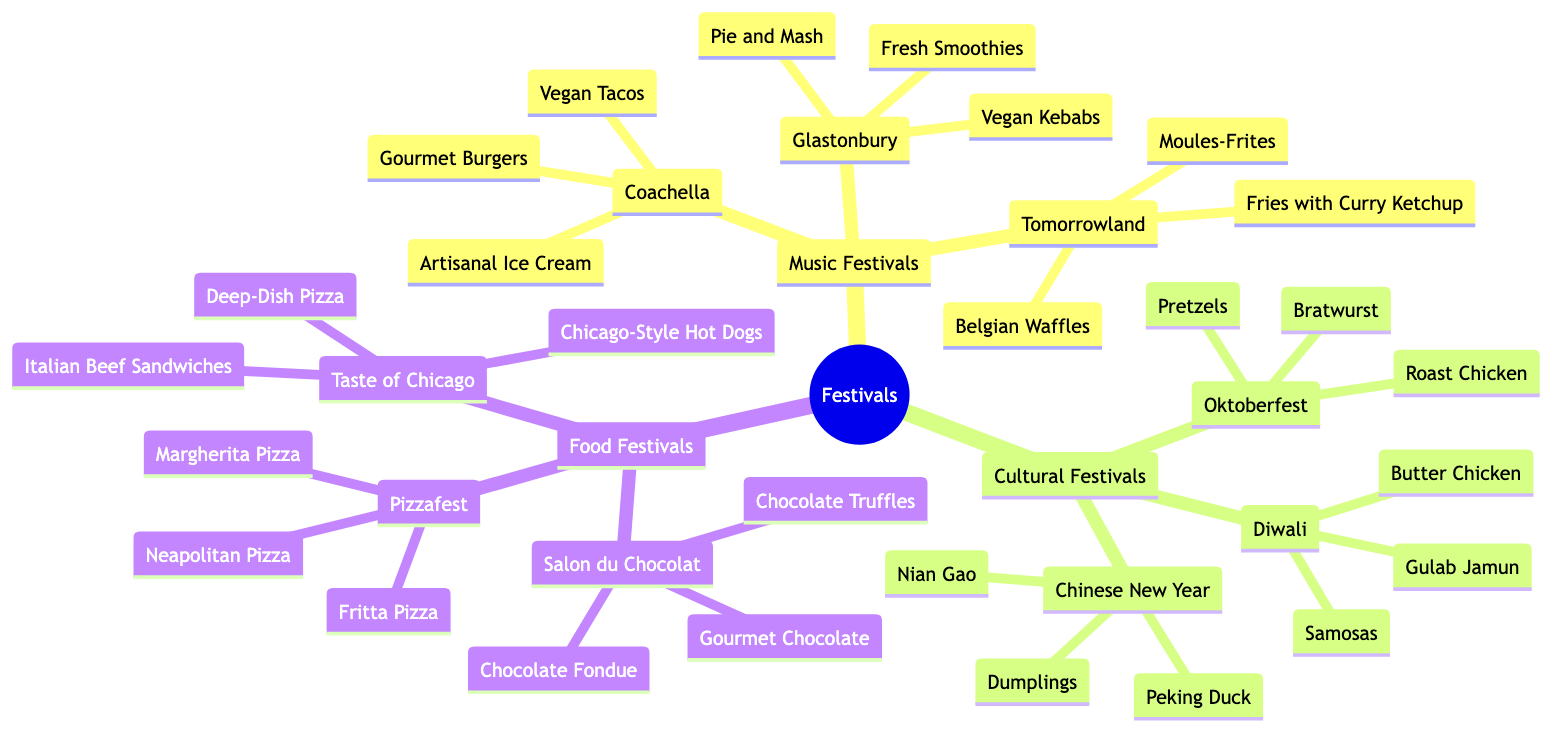What type of festival is Coachella? Coachella is categorized under Music Festivals in the diagram. This node directly connects to the main category of Festivals and has multiple sub-nodes representing its food offerings.
Answer: Music Festival How many food offerings are listed for Oktoberfest? Oktoberfest has three food offerings listed: Bratwurst, Pretzels, and Roast Chicken. Therefore, counting these offerings gives us a total of three.
Answer: 3 What is a unique food offering at Tomorrowland? Tomorrowland has Belgian Waffles listed as one of its unique food offerings. It is part of the Music Festivals category and stands out among its food options.
Answer: Belgian Waffles Which festival features chocolate? The Salon du Chocolat features gourmet chocolate and other chocolate-related offerings. This festival appears under Food Festivals in the diagram.
Answer: Salon du Chocolat Which two festivals have vegan food options? The festivals with vegan food options are Coachella and Glastonbury. Coachella includes Vegan Tacos, while Glastonbury has Vegan Kebabs, indicating that both cater to vegan diets.
Answer: Coachella and Glastonbury What type of dish is commonly found at both Diwali and Oktoberfest? Both festivals feature savory dishes; Diwali has Butter Chicken and Oktoberfest has Bratwurst. By examining their respective food offerings, we see they both include popular savory options.
Answer: Savory dish Which festival is known for its Peking Duck offering? Peking Duck is a food offering found under the Chinese New Year festival. This connects to the Cultural Festivals category in the diagram.
Answer: Chinese New Year How many total food offerings are there in the Food Festivals category? In the Food Festivals category, there are three festivals, each with three offerings. Therefore, there are a total of nine food offerings in this category (3 festivals × 3 offerings each = 9).
Answer: 9 Which festival occurs in Munich? Oktoberfest takes place in Munich, as stated in the diagram under the Cultural Festivals category.
Answer: Oktoberfest 